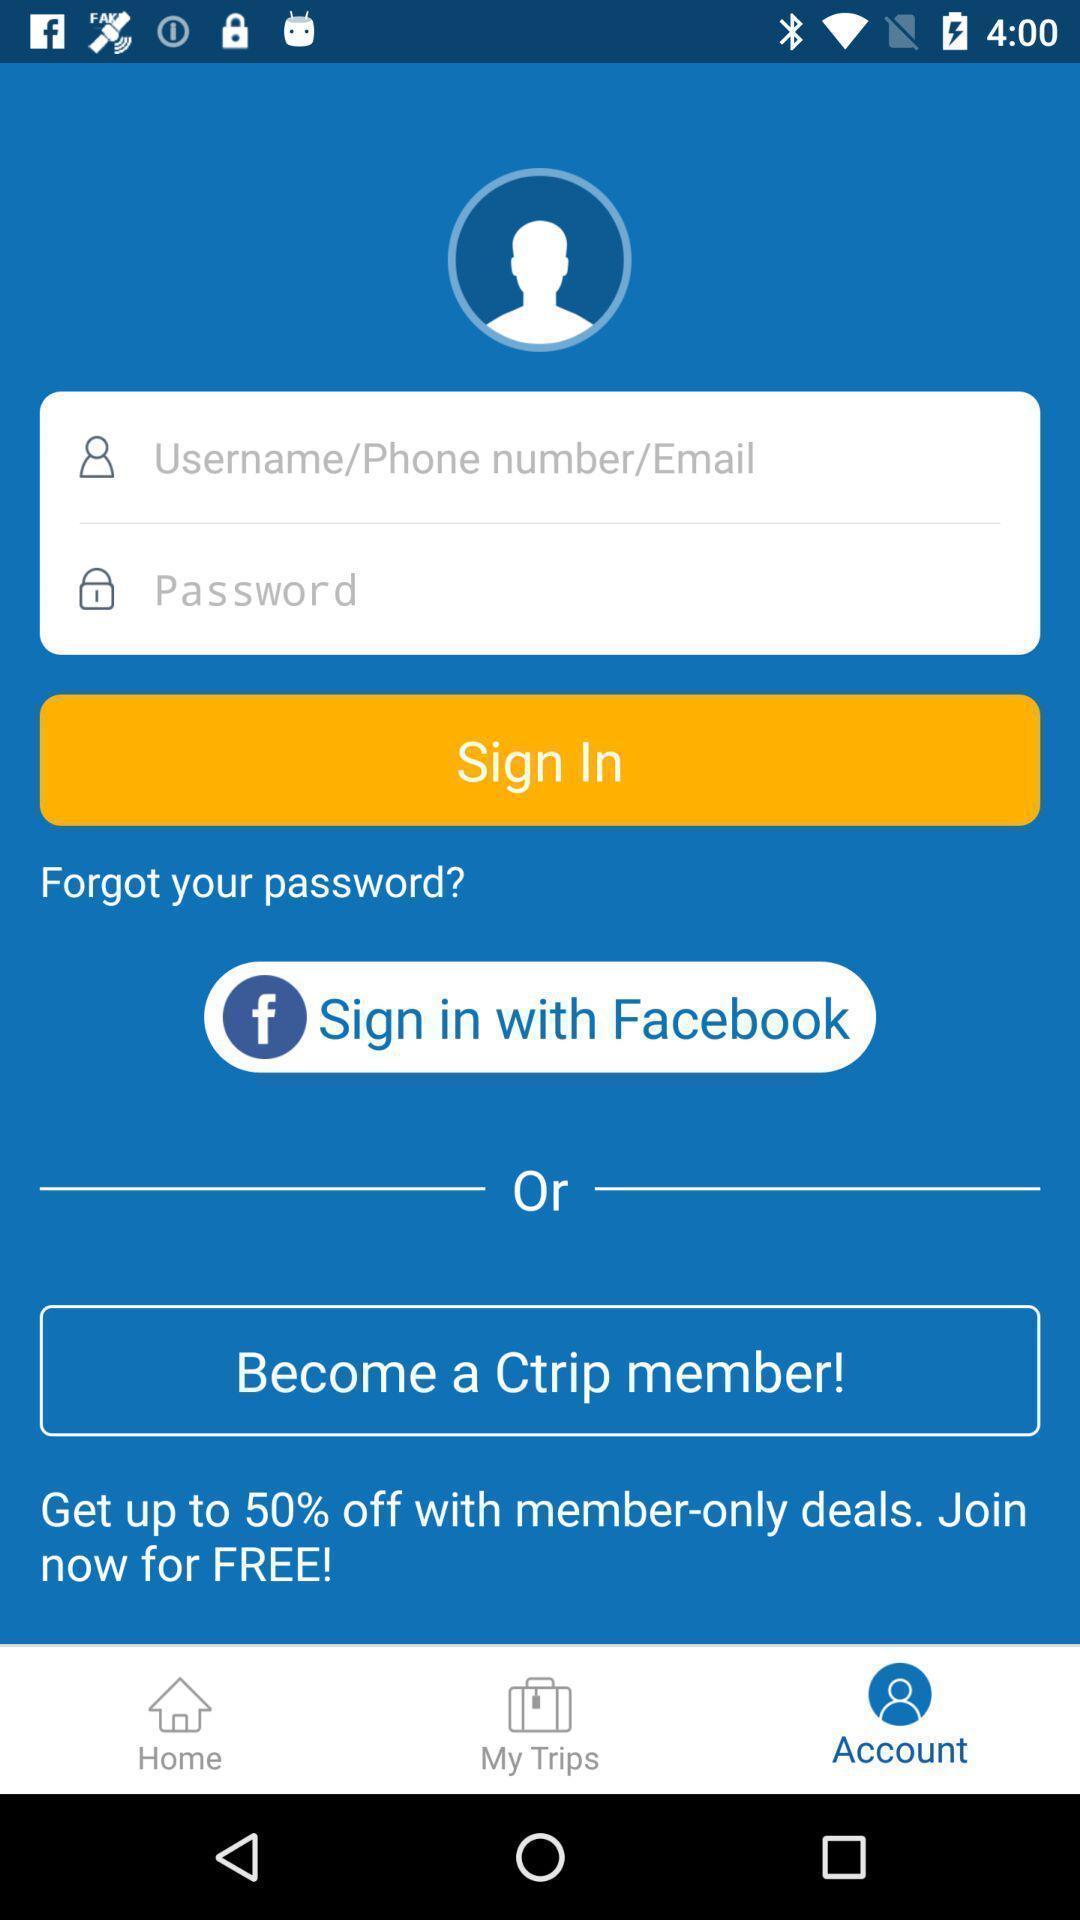Describe the content in this image. Welcome page to create an account. 